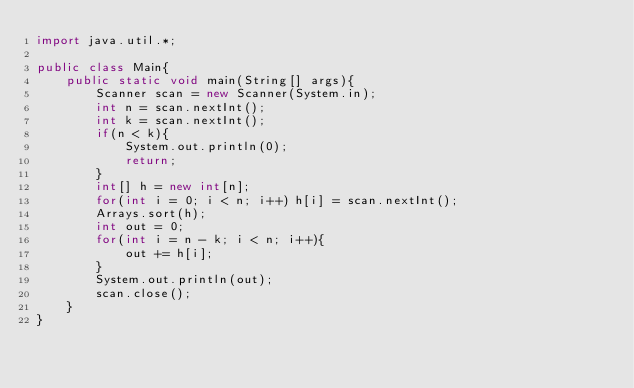<code> <loc_0><loc_0><loc_500><loc_500><_Java_>import java.util.*;

public class Main{
    public static void main(String[] args){
        Scanner scan = new Scanner(System.in);
        int n = scan.nextInt();
        int k = scan.nextInt();
        if(n < k){
            System.out.println(0);
            return;
        }
        int[] h = new int[n];
        for(int i = 0; i < n; i++) h[i] = scan.nextInt();
        Arrays.sort(h);
        int out = 0; 
        for(int i = n - k; i < n; i++){
            out += h[i];
        }
        System.out.println(out);
        scan.close();
    }
}</code> 